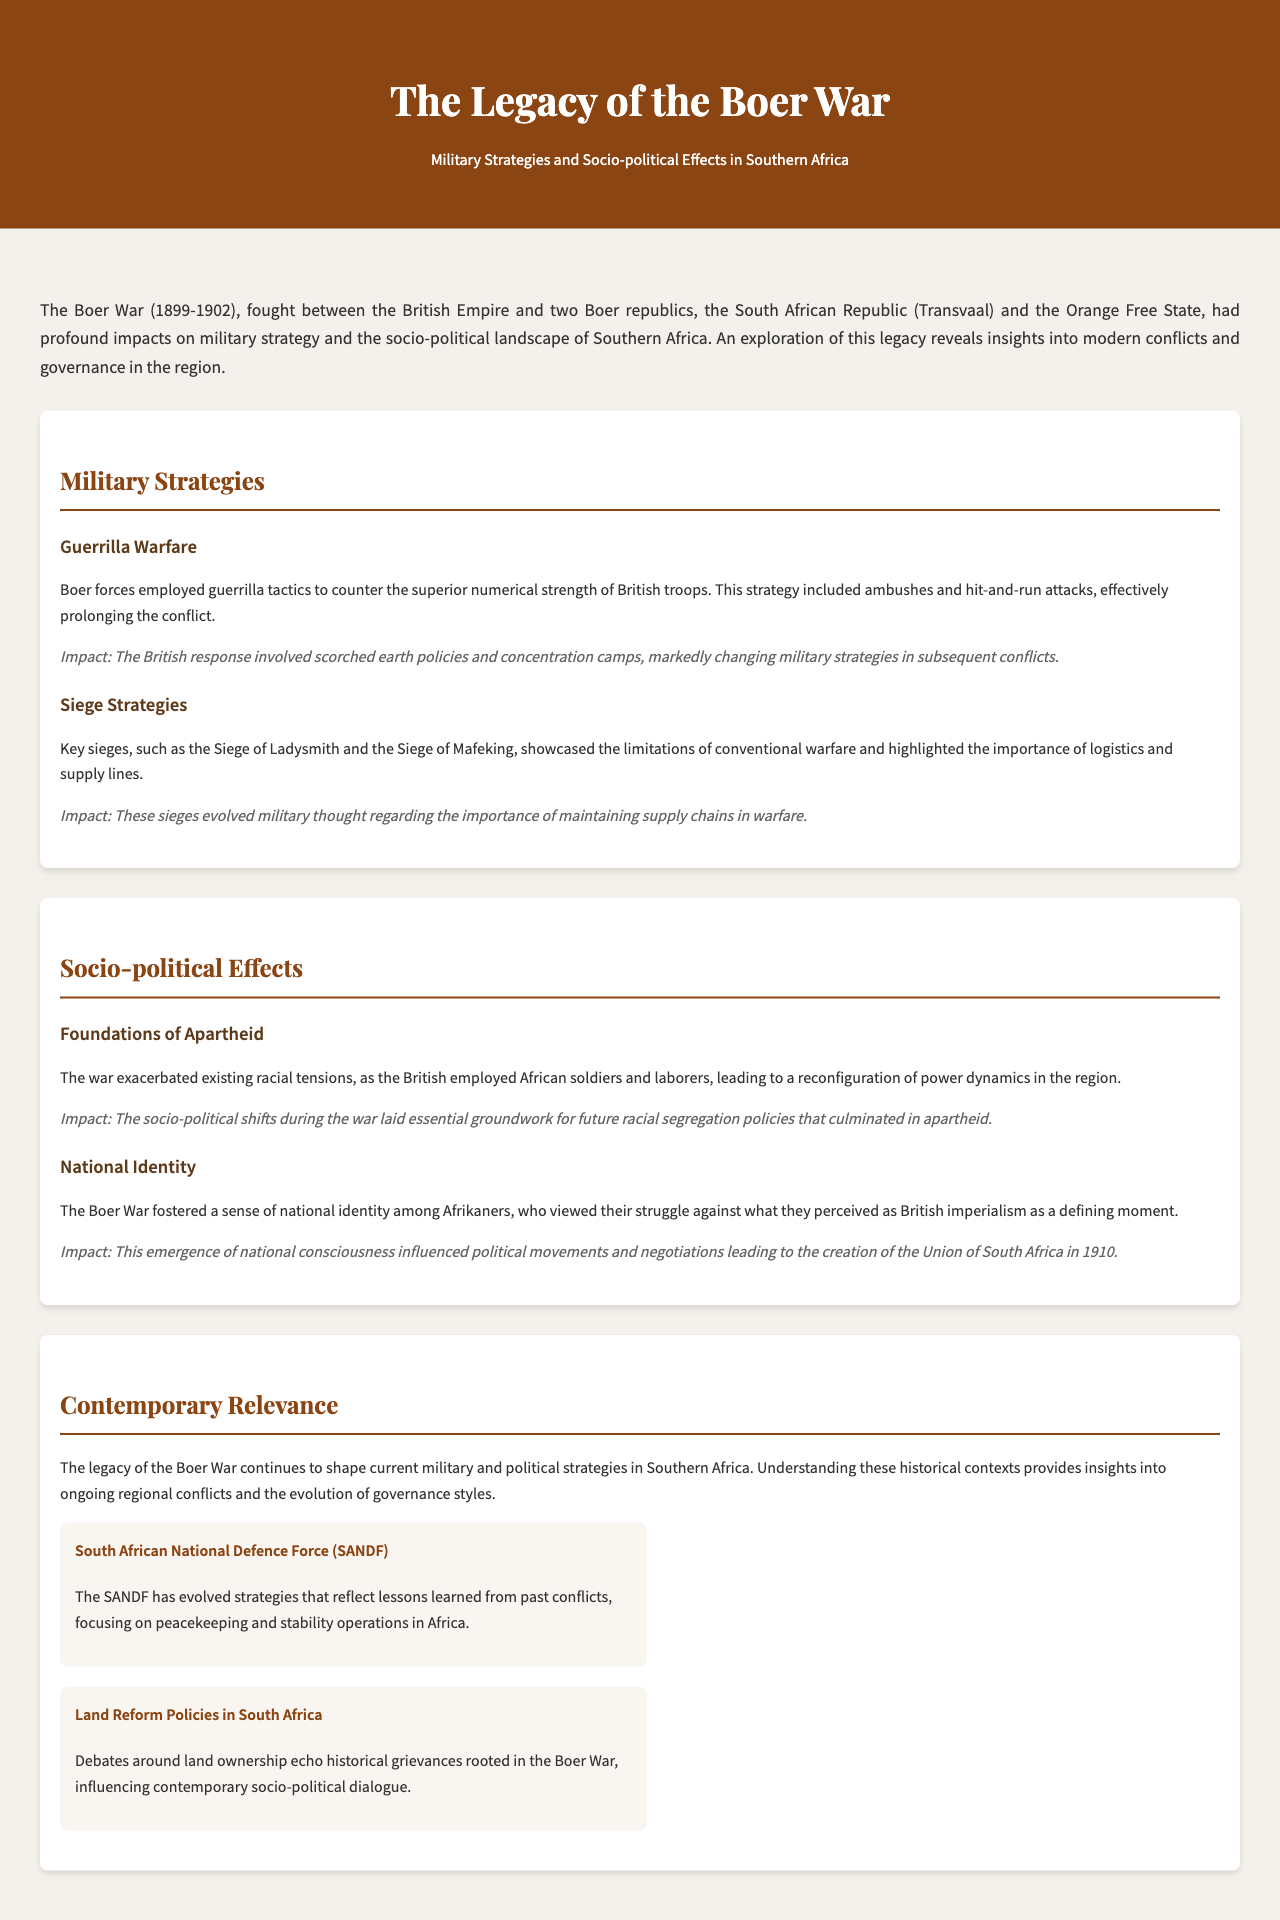What years did the Boer War take place? The document mentions that the Boer War was fought between 1899 and 1902.
Answer: 1899-1902 What two Boer republics were involved in the war? The brochure states that the two Boer republics involved were the South African Republic (Transvaal) and the Orange Free State.
Answer: South African Republic (Transvaal) and the Orange Free State What military strategy did Boer forces employ against British troops? The document notes that Boer forces employed guerrilla tactics to counter British numerical superiority.
Answer: Guerrilla warfare What was one of the impacts of employing guerrilla tactics? The impact mentioned in the document was the British response involving scorched earth policies and concentration camps.
Answer: Scorched earth policies and concentration camps What did the Boer War exacerbate in terms of social dynamics? The document indicates that the war exacerbated existing racial tensions, particularly regarding the employment of African soldiers and laborers.
Answer: Racial tensions What significant political development occurred in 1910 as a result of the Boer War's legacy? The brochure explains that the emergence of national consciousness influenced political movements leading to the creation of the Union of South Africa in 1910.
Answer: Union of South Africa How does the legacy of the Boer War impact current military strategies? According to the document, understanding the legacy shapes current military and political strategies in Southern Africa.
Answer: Current military and political strategies What organization continues to reflect lessons learned from past conflicts in Southern Africa? The document mentions the South African National Defence Force (SANDF) as an organization that has evolved strategies based on past conflicts.
Answer: South African National Defence Force (SANDF) 